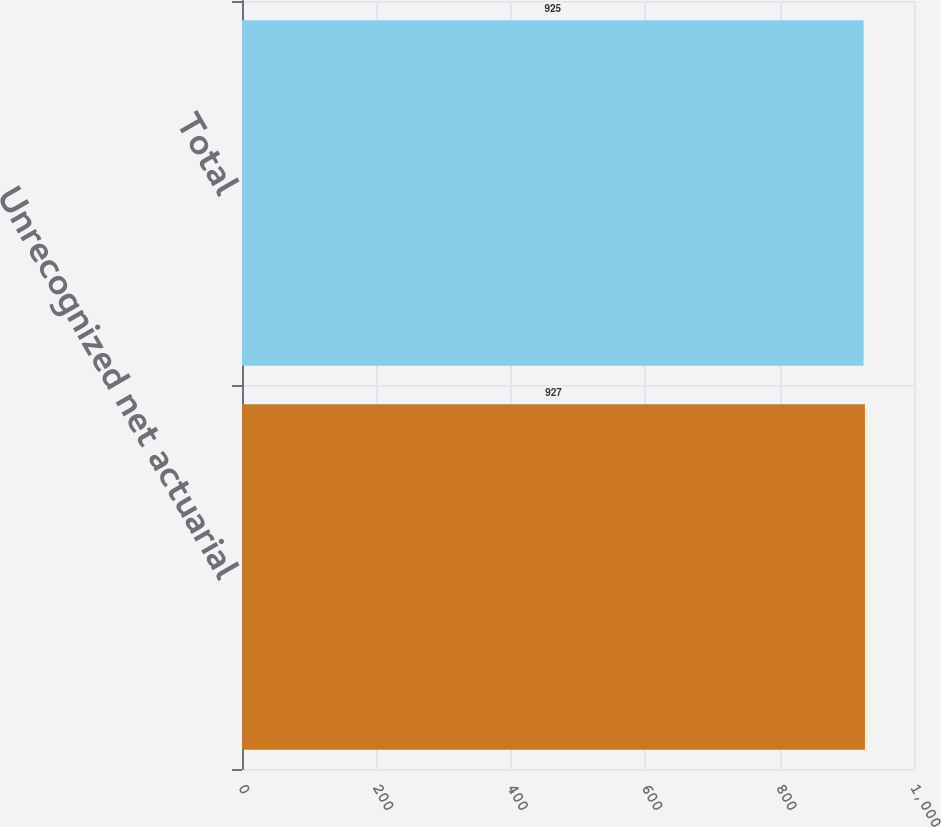Convert chart to OTSL. <chart><loc_0><loc_0><loc_500><loc_500><bar_chart><fcel>Unrecognized net actuarial<fcel>Total<nl><fcel>927<fcel>925<nl></chart> 